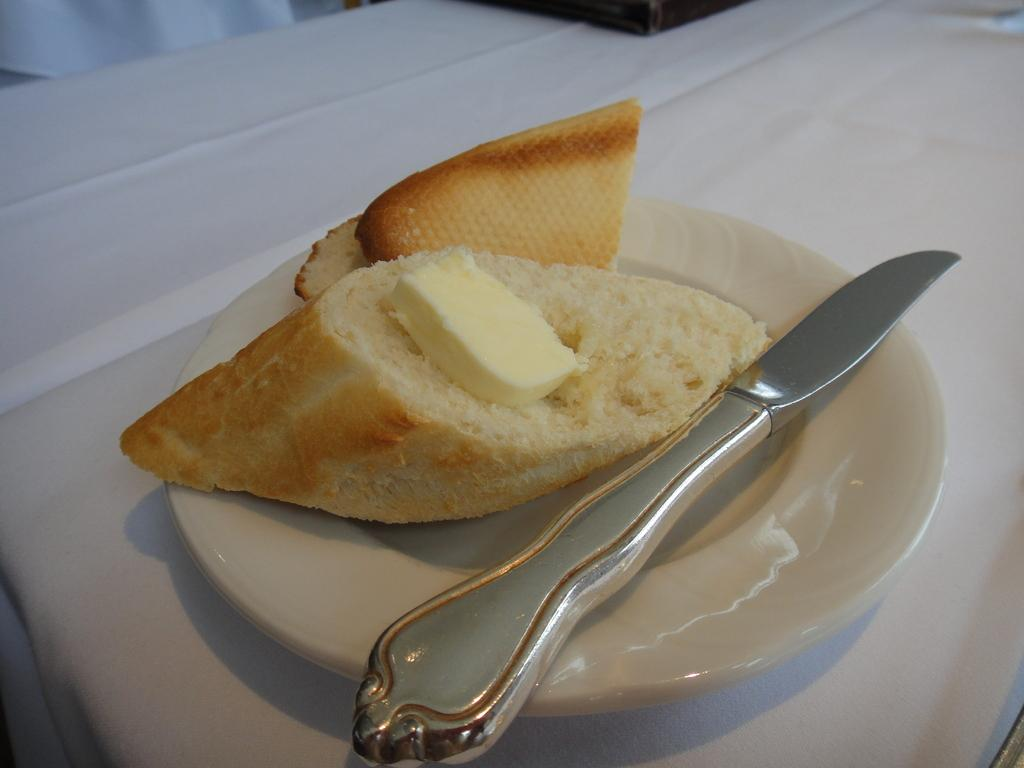What is on the white surface in the image? There is a white plate in the image. What is on the plate? The plate contains breads. What accompanies the breads on the plate? There is butter on the breads. Is there any utensil or tool present in the image? Yes, there is a knife on the plate or near the plate. How many sheep can be seen grazing on the wood in the image? There are no sheep or wood present in the image; it features a white plate with breads and butter. 